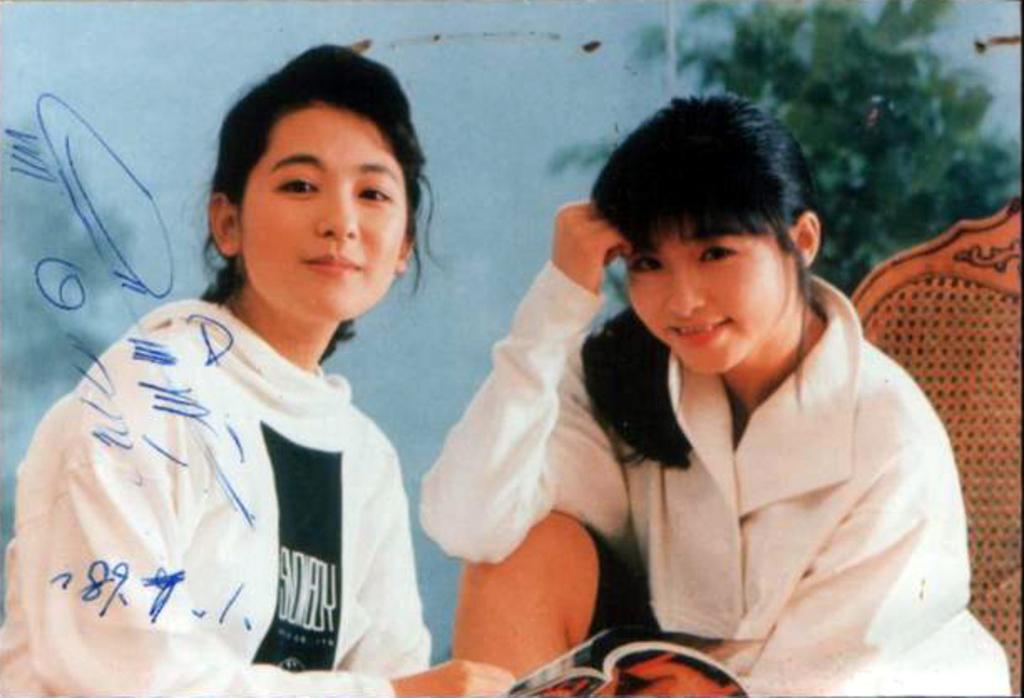How many people are present in the image? There are two people in the image. What can be seen in the background of the image? There is a tree and a wall in the background of the image. What type of notebook is being used by the people in the image? There is no notebook present in the image. How do the people in the image push the tree in the background? The people in the image are not pushing the tree; they are simply standing in front of it. 